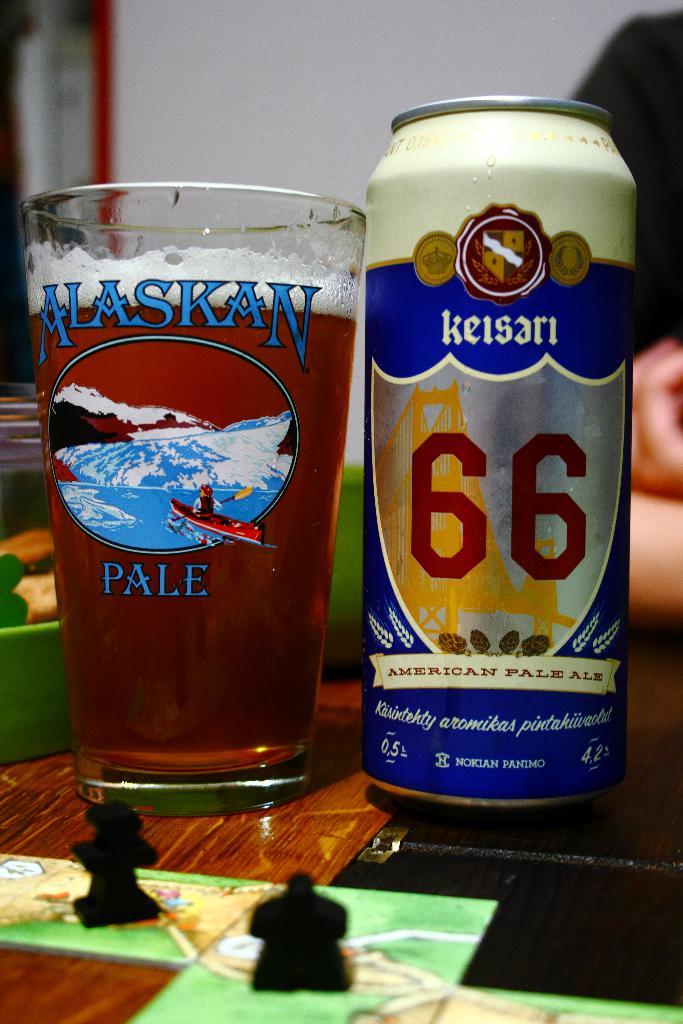What is the brand of beer, according to the glass?
Your answer should be very brief. Alaskan pale. What kind of ale is it?
Provide a succinct answer. American pale ale. 